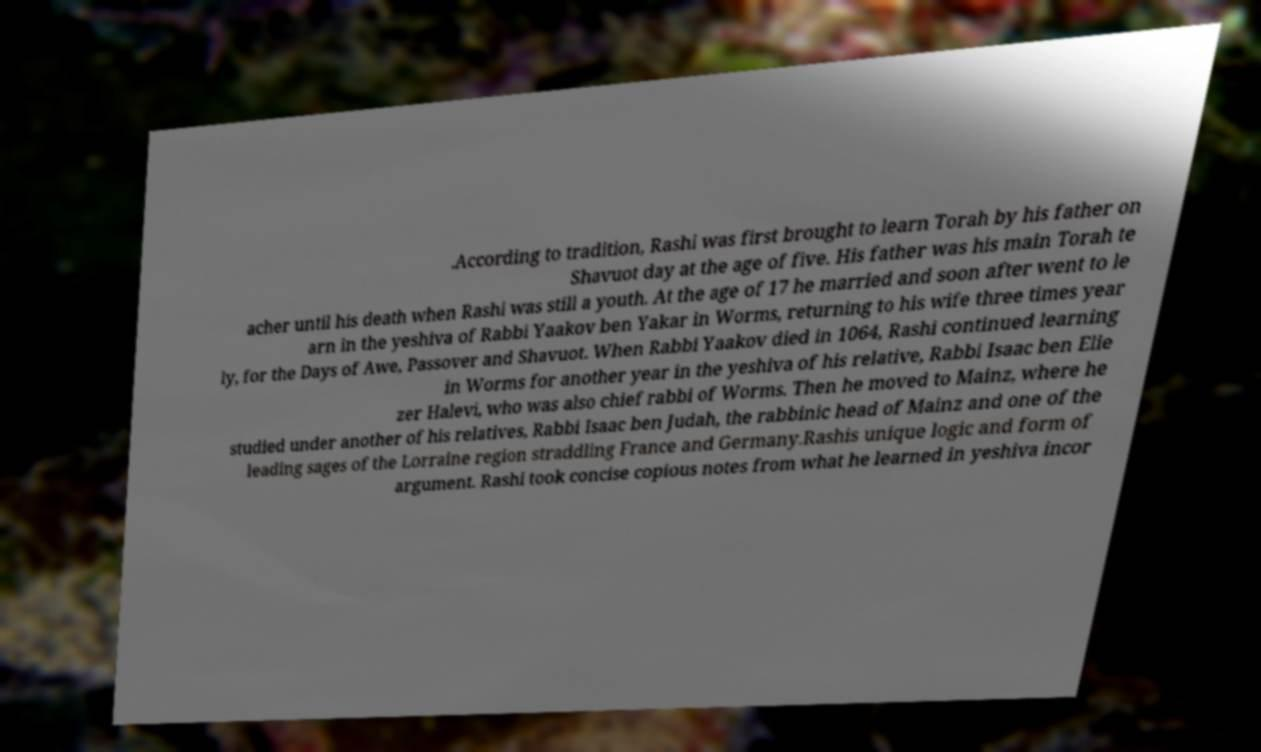Please identify and transcribe the text found in this image. .According to tradition, Rashi was first brought to learn Torah by his father on Shavuot day at the age of five. His father was his main Torah te acher until his death when Rashi was still a youth. At the age of 17 he married and soon after went to le arn in the yeshiva of Rabbi Yaakov ben Yakar in Worms, returning to his wife three times year ly, for the Days of Awe, Passover and Shavuot. When Rabbi Yaakov died in 1064, Rashi continued learning in Worms for another year in the yeshiva of his relative, Rabbi Isaac ben Elie zer Halevi, who was also chief rabbi of Worms. Then he moved to Mainz, where he studied under another of his relatives, Rabbi Isaac ben Judah, the rabbinic head of Mainz and one of the leading sages of the Lorraine region straddling France and Germany.Rashis unique logic and form of argument. Rashi took concise copious notes from what he learned in yeshiva incor 